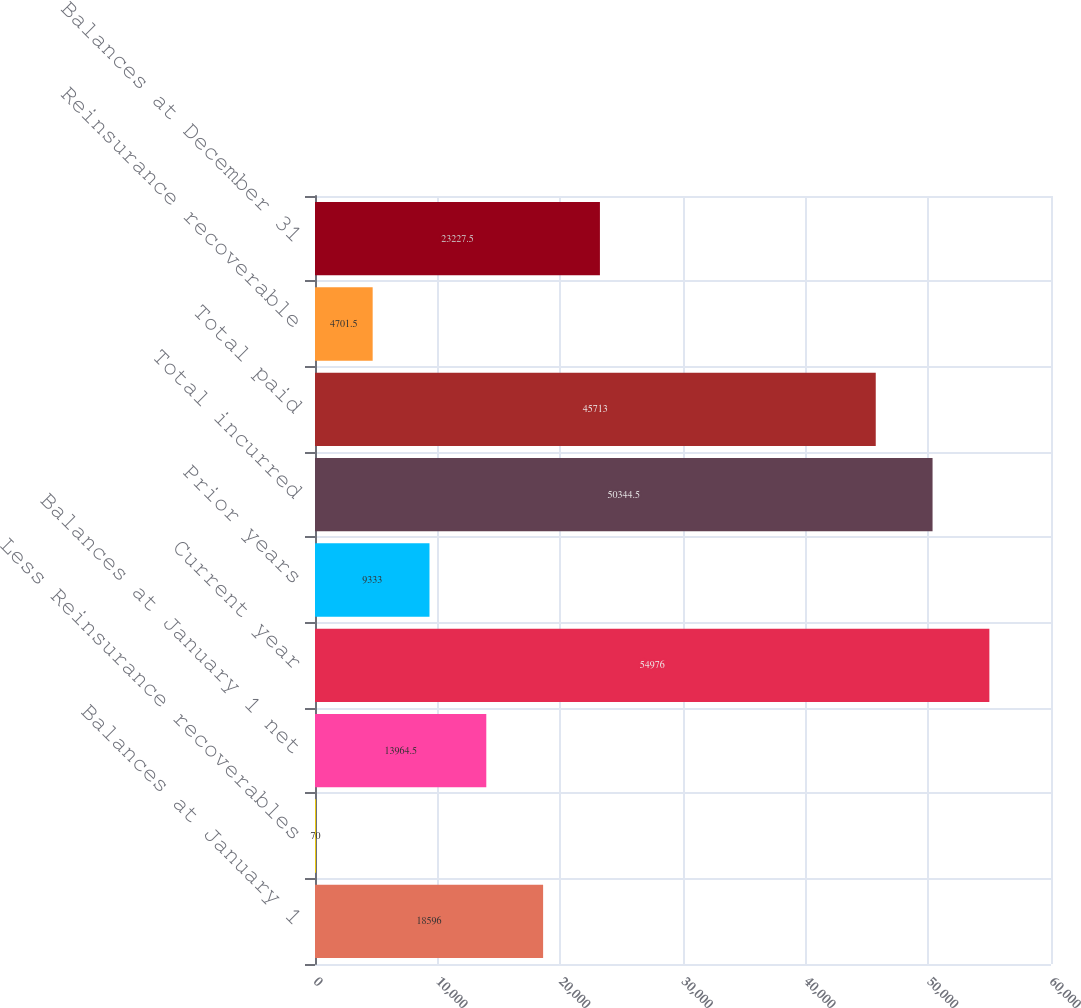Convert chart. <chart><loc_0><loc_0><loc_500><loc_500><bar_chart><fcel>Balances at January 1<fcel>Less Reinsurance recoverables<fcel>Balances at January 1 net<fcel>Current year<fcel>Prior years<fcel>Total incurred<fcel>Total paid<fcel>Reinsurance recoverable<fcel>Balances at December 31<nl><fcel>18596<fcel>70<fcel>13964.5<fcel>54976<fcel>9333<fcel>50344.5<fcel>45713<fcel>4701.5<fcel>23227.5<nl></chart> 